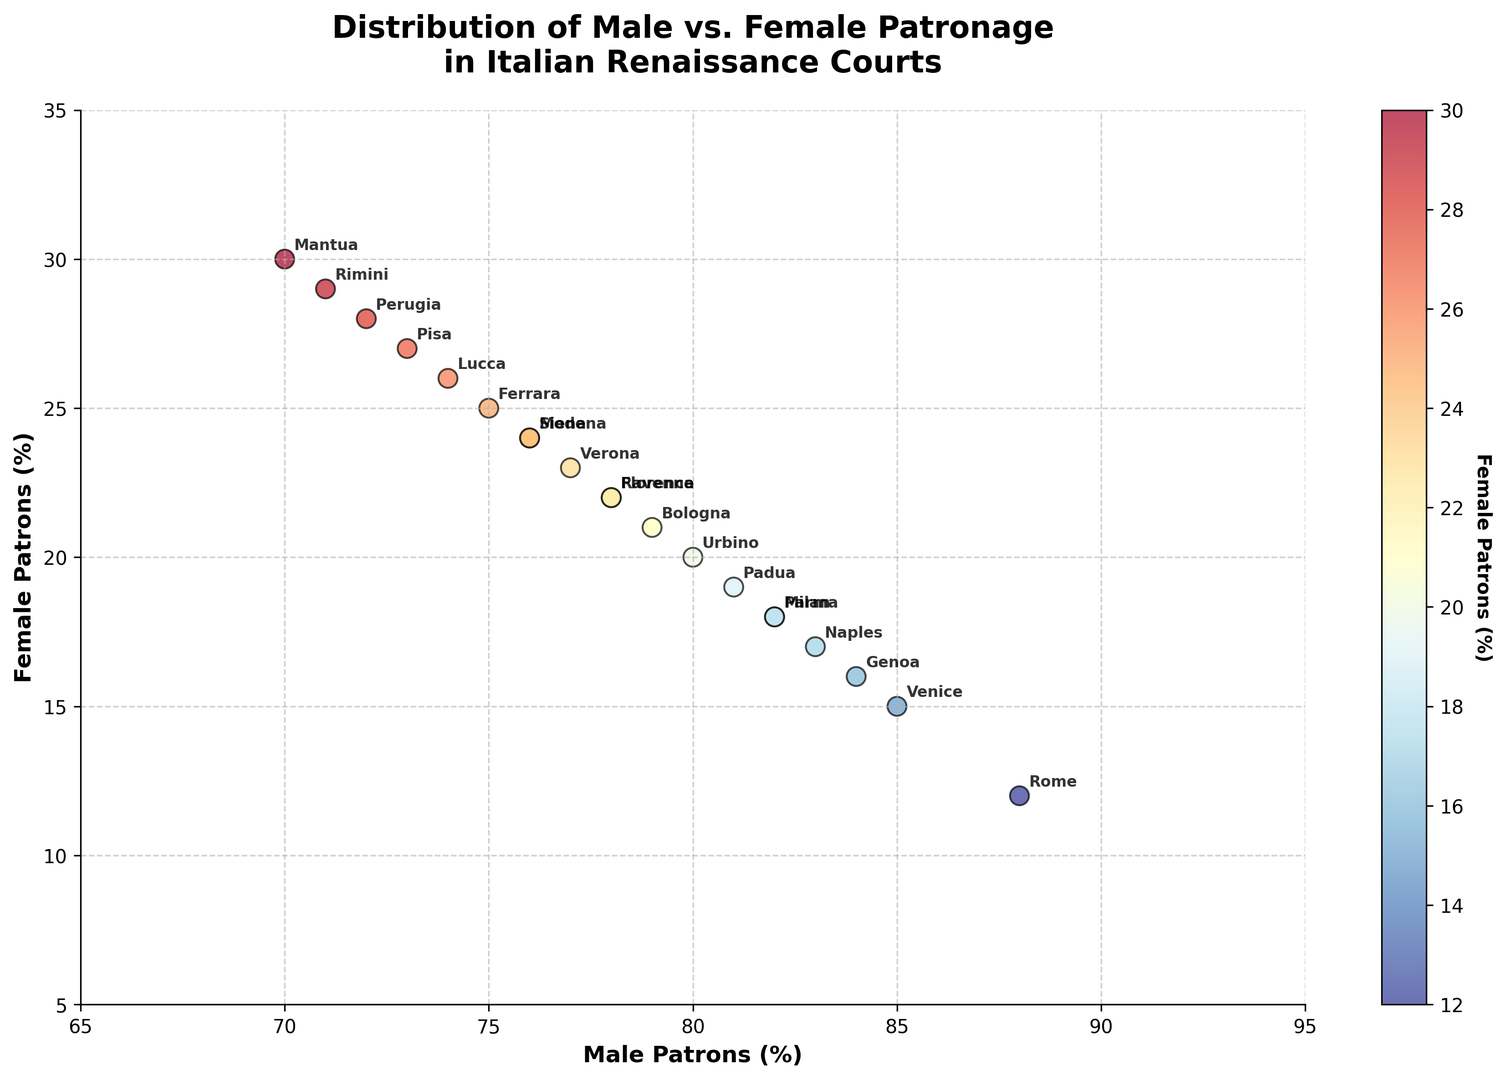What court has the highest proportion of male patrons? Referring to the scatter plot, the court with the highest proportion of male patrons would be the one with the highest value on the x-axis. This highest value is 88%, which corresponds to Rome.
Answer: Rome Which court has the highest proportion of female patrons? Referring to the scatter plot, the court with the highest value on the y-axis has the highest proportion of female patrons. This highest value is 30%, which corresponds to Mantua.
Answer: Mantua What is the difference between the male patronage percentage in Florence and Venice? To find the difference, subtract the proportion of male patrons in Venice (85%) from that in Florence (78%). 85% - 78% = 7%.
Answer: 7% How many courts have a higher proportion of female patrons than Pisa? Pisa's female patronage is 27%. Referring to the scatter plot, Mantua (30%) and Perugia (28%) have higher percentages, making it two courts.
Answer: 2 Which court has the closest balance between male and female patrons? The best balance can be found by looking at the point closest to the 45-degree line where male and female patrons would be equal. Mantua, with male patrons at 70% and female patrons at 30%, shows the closest balance among the presented data.
Answer: Mantua In terms of female patronage, which court is closest in value to Perugia? Perugia has 28% female patrons. The court closest to this value visually on the y-axis is Rimini, with 29% female patrons.
Answer: Rimini What is the range of male patronage percentages? To find the range, subtract the smallest value of male patronage (Mantua at 70%) from the largest value (Rome at 88%). 88% - 70% = 18%.
Answer: 18% Which court has the closest proportions of male patrons to Naples? Naples has 83% male patrons. Courts with close values are Milan, Parma, and Padua, all having 82% male patrons.
Answer: Milan, Parma, Padua If the female patronage percentage is used as a heatmap color, which court will appear more prominently with a blue shade? The scatter plot uses a red-to-blue color map where blue indicates higher female patronage. Mantua, with the highest female patronage at 30%, will appear more prominently blue.
Answer: Mantua 